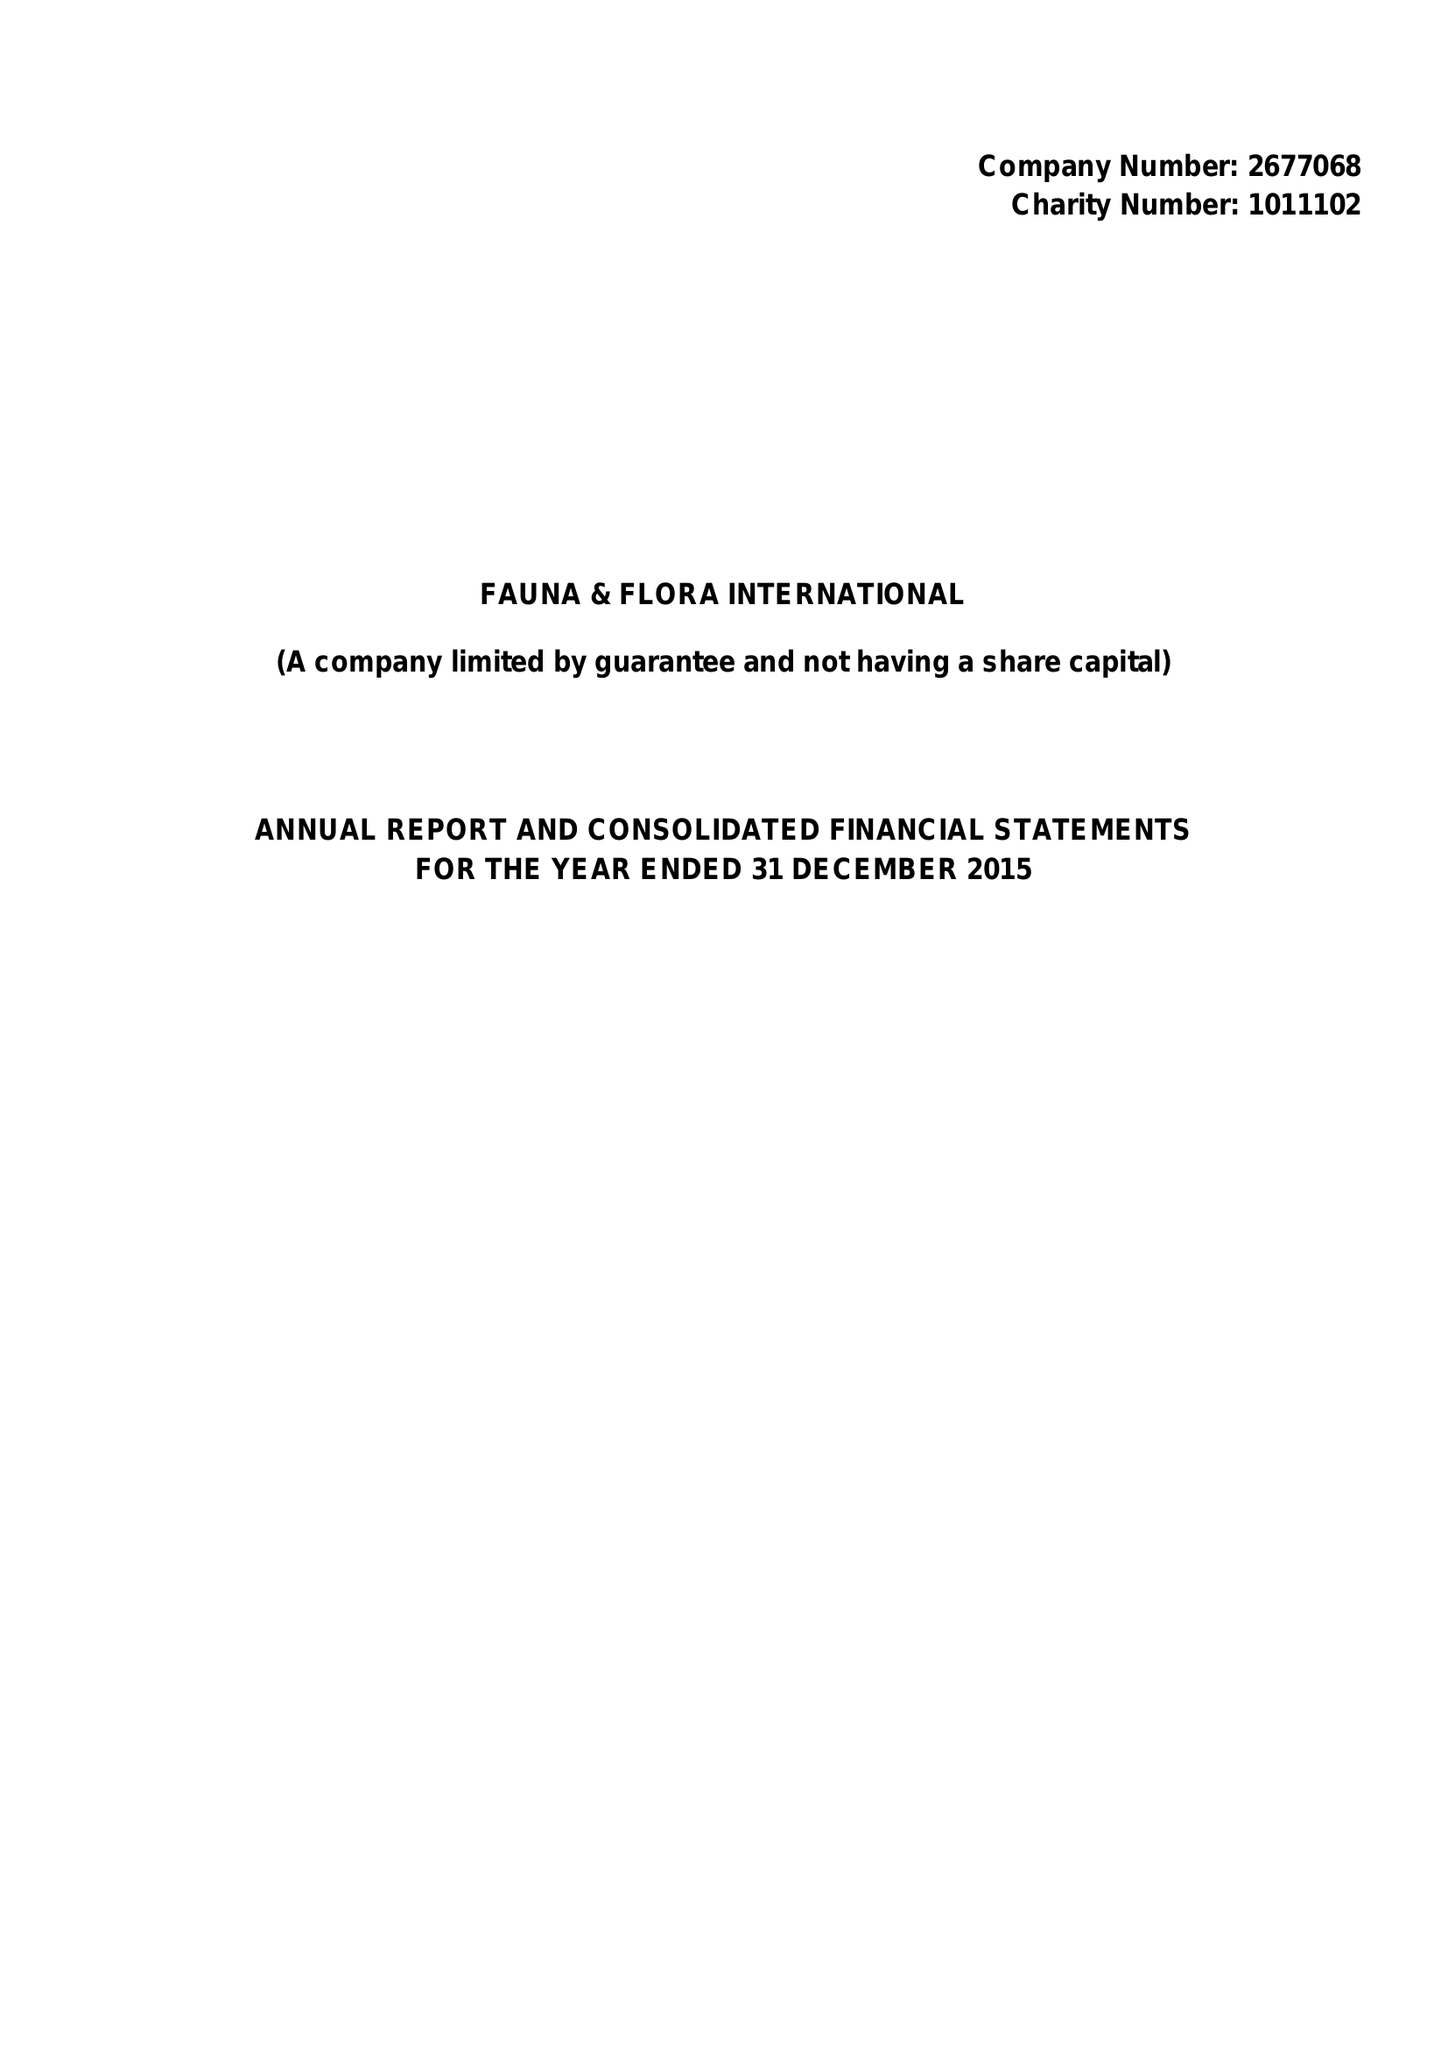What is the value for the address__postcode?
Answer the question using a single word or phrase. CB2 3QZ 